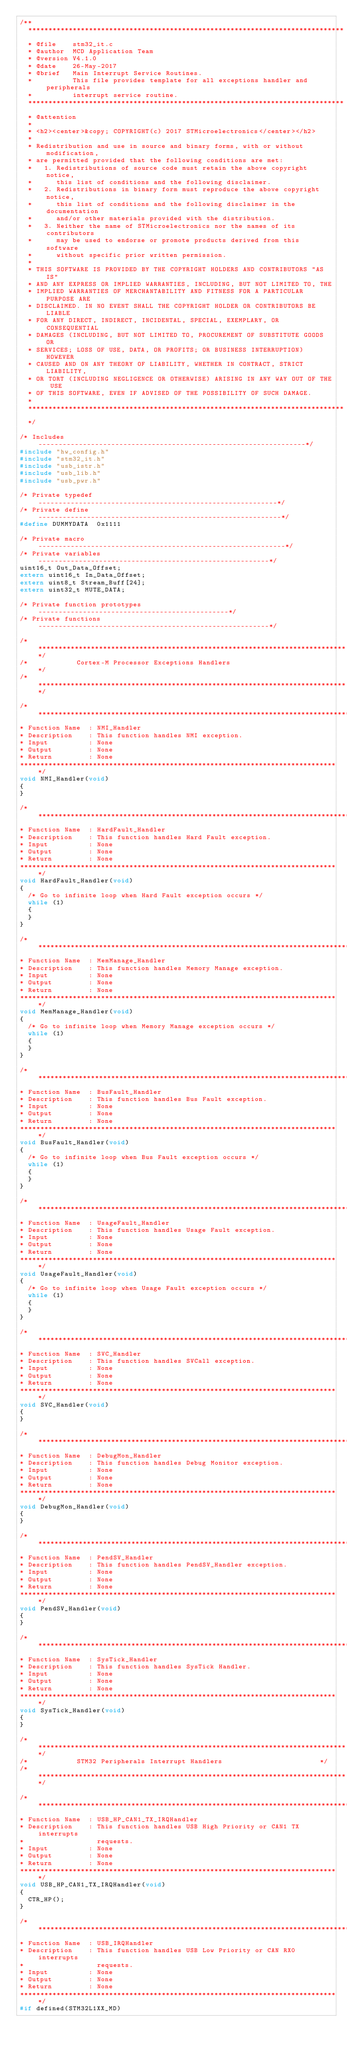Convert code to text. <code><loc_0><loc_0><loc_500><loc_500><_C_>/**
  ******************************************************************************
  * @file    stm32_it.c
  * @author  MCD Application Team
  * @version V4.1.0
  * @date    26-May-2017
  * @brief   Main Interrupt Service Routines.
  *          This file provides template for all exceptions handler and peripherals
  *          interrupt service routine.
  ******************************************************************************
  * @attention
  *
  * <h2><center>&copy; COPYRIGHT(c) 2017 STMicroelectronics</center></h2>
  *
  * Redistribution and use in source and binary forms, with or without modification,
  * are permitted provided that the following conditions are met:
  *   1. Redistributions of source code must retain the above copyright notice,
  *      this list of conditions and the following disclaimer.
  *   2. Redistributions in binary form must reproduce the above copyright notice,
  *      this list of conditions and the following disclaimer in the documentation
  *      and/or other materials provided with the distribution.
  *   3. Neither the name of STMicroelectronics nor the names of its contributors
  *      may be used to endorse or promote products derived from this software
  *      without specific prior written permission.
  *
  * THIS SOFTWARE IS PROVIDED BY THE COPYRIGHT HOLDERS AND CONTRIBUTORS "AS IS"
  * AND ANY EXPRESS OR IMPLIED WARRANTIES, INCLUDING, BUT NOT LIMITED TO, THE
  * IMPLIED WARRANTIES OF MERCHANTABILITY AND FITNESS FOR A PARTICULAR PURPOSE ARE
  * DISCLAIMED. IN NO EVENT SHALL THE COPYRIGHT HOLDER OR CONTRIBUTORS BE LIABLE
  * FOR ANY DIRECT, INDIRECT, INCIDENTAL, SPECIAL, EXEMPLARY, OR CONSEQUENTIAL
  * DAMAGES (INCLUDING, BUT NOT LIMITED TO, PROCUREMENT OF SUBSTITUTE GOODS OR
  * SERVICES; LOSS OF USE, DATA, OR PROFITS; OR BUSINESS INTERRUPTION) HOWEVER
  * CAUSED AND ON ANY THEORY OF LIABILITY, WHETHER IN CONTRACT, STRICT LIABILITY,
  * OR TORT (INCLUDING NEGLIGENCE OR OTHERWISE) ARISING IN ANY WAY OUT OF THE USE
  * OF THIS SOFTWARE, EVEN IF ADVISED OF THE POSSIBILITY OF SUCH DAMAGE.
  *
  ******************************************************************************
  */

/* Includes ------------------------------------------------------------------*/
#include "hw_config.h"
#include "stm32_it.h"
#include "usb_istr.h"
#include "usb_lib.h"
#include "usb_pwr.h"

/* Private typedef -----------------------------------------------------------*/
/* Private define ------------------------------------------------------------*/
#define DUMMYDATA  0x1111

/* Private macro -------------------------------------------------------------*/
/* Private variables ---------------------------------------------------------*/
uint16_t Out_Data_Offset;
extern uint16_t In_Data_Offset;
extern uint8_t Stream_Buff[24];
extern uint32_t MUTE_DATA;

/* Private function prototypes -----------------------------------------------*/
/* Private functions ---------------------------------------------------------*/

/******************************************************************************/
/*            Cortex-M Processor Exceptions Handlers                         */
/******************************************************************************/

/*******************************************************************************
* Function Name  : NMI_Handler
* Description    : This function handles NMI exception.
* Input          : None
* Output         : None
* Return         : None
*******************************************************************************/
void NMI_Handler(void)
{
}

/*******************************************************************************
* Function Name  : HardFault_Handler
* Description    : This function handles Hard Fault exception.
* Input          : None
* Output         : None
* Return         : None
*******************************************************************************/
void HardFault_Handler(void)
{
  /* Go to infinite loop when Hard Fault exception occurs */
  while (1)
  {
  }
}

/*******************************************************************************
* Function Name  : MemManage_Handler
* Description    : This function handles Memory Manage exception.
* Input          : None
* Output         : None
* Return         : None
*******************************************************************************/
void MemManage_Handler(void)
{
  /* Go to infinite loop when Memory Manage exception occurs */
  while (1)
  {
  }
}

/*******************************************************************************
* Function Name  : BusFault_Handler
* Description    : This function handles Bus Fault exception.
* Input          : None
* Output         : None
* Return         : None
*******************************************************************************/
void BusFault_Handler(void)
{
  /* Go to infinite loop when Bus Fault exception occurs */
  while (1)
  {
  }
}

/*******************************************************************************
* Function Name  : UsageFault_Handler
* Description    : This function handles Usage Fault exception.
* Input          : None
* Output         : None
* Return         : None
*******************************************************************************/
void UsageFault_Handler(void)
{
  /* Go to infinite loop when Usage Fault exception occurs */
  while (1)
  {
  }
}

/*******************************************************************************
* Function Name  : SVC_Handler
* Description    : This function handles SVCall exception.
* Input          : None
* Output         : None
* Return         : None
*******************************************************************************/
void SVC_Handler(void)
{
}

/*******************************************************************************
* Function Name  : DebugMon_Handler
* Description    : This function handles Debug Monitor exception.
* Input          : None
* Output         : None
* Return         : None
*******************************************************************************/
void DebugMon_Handler(void)
{
}

/*******************************************************************************
* Function Name  : PendSV_Handler
* Description    : This function handles PendSV_Handler exception.
* Input          : None
* Output         : None
* Return         : None
*******************************************************************************/
void PendSV_Handler(void)
{
}

/*******************************************************************************
* Function Name  : SysTick_Handler
* Description    : This function handles SysTick Handler.
* Input          : None
* Output         : None
* Return         : None
*******************************************************************************/
void SysTick_Handler(void)
{
}

/******************************************************************************/
/*            STM32 Peripherals Interrupt Handlers                        */
/******************************************************************************/

/*******************************************************************************
* Function Name  : USB_HP_CAN1_TX_IRQHandler
* Description    : This function handles USB High Priority or CAN1 TX interrupts
*                  requests.
* Input          : None
* Output         : None
* Return         : None
*******************************************************************************/
void USB_HP_CAN1_TX_IRQHandler(void)
{
  CTR_HP();
}

/*******************************************************************************
* Function Name  : USB_IRQHandler
* Description    : This function handles USB Low Priority or CAN RX0 interrupts
*                  requests.
* Input          : None
* Output         : None
* Return         : None
*******************************************************************************/
#if defined(STM32L1XX_MD)</code> 